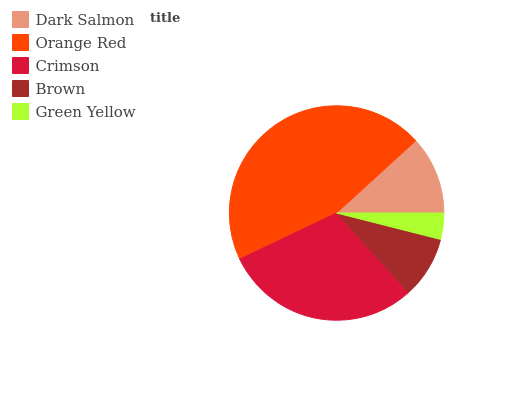Is Green Yellow the minimum?
Answer yes or no. Yes. Is Orange Red the maximum?
Answer yes or no. Yes. Is Crimson the minimum?
Answer yes or no. No. Is Crimson the maximum?
Answer yes or no. No. Is Orange Red greater than Crimson?
Answer yes or no. Yes. Is Crimson less than Orange Red?
Answer yes or no. Yes. Is Crimson greater than Orange Red?
Answer yes or no. No. Is Orange Red less than Crimson?
Answer yes or no. No. Is Dark Salmon the high median?
Answer yes or no. Yes. Is Dark Salmon the low median?
Answer yes or no. Yes. Is Green Yellow the high median?
Answer yes or no. No. Is Crimson the low median?
Answer yes or no. No. 